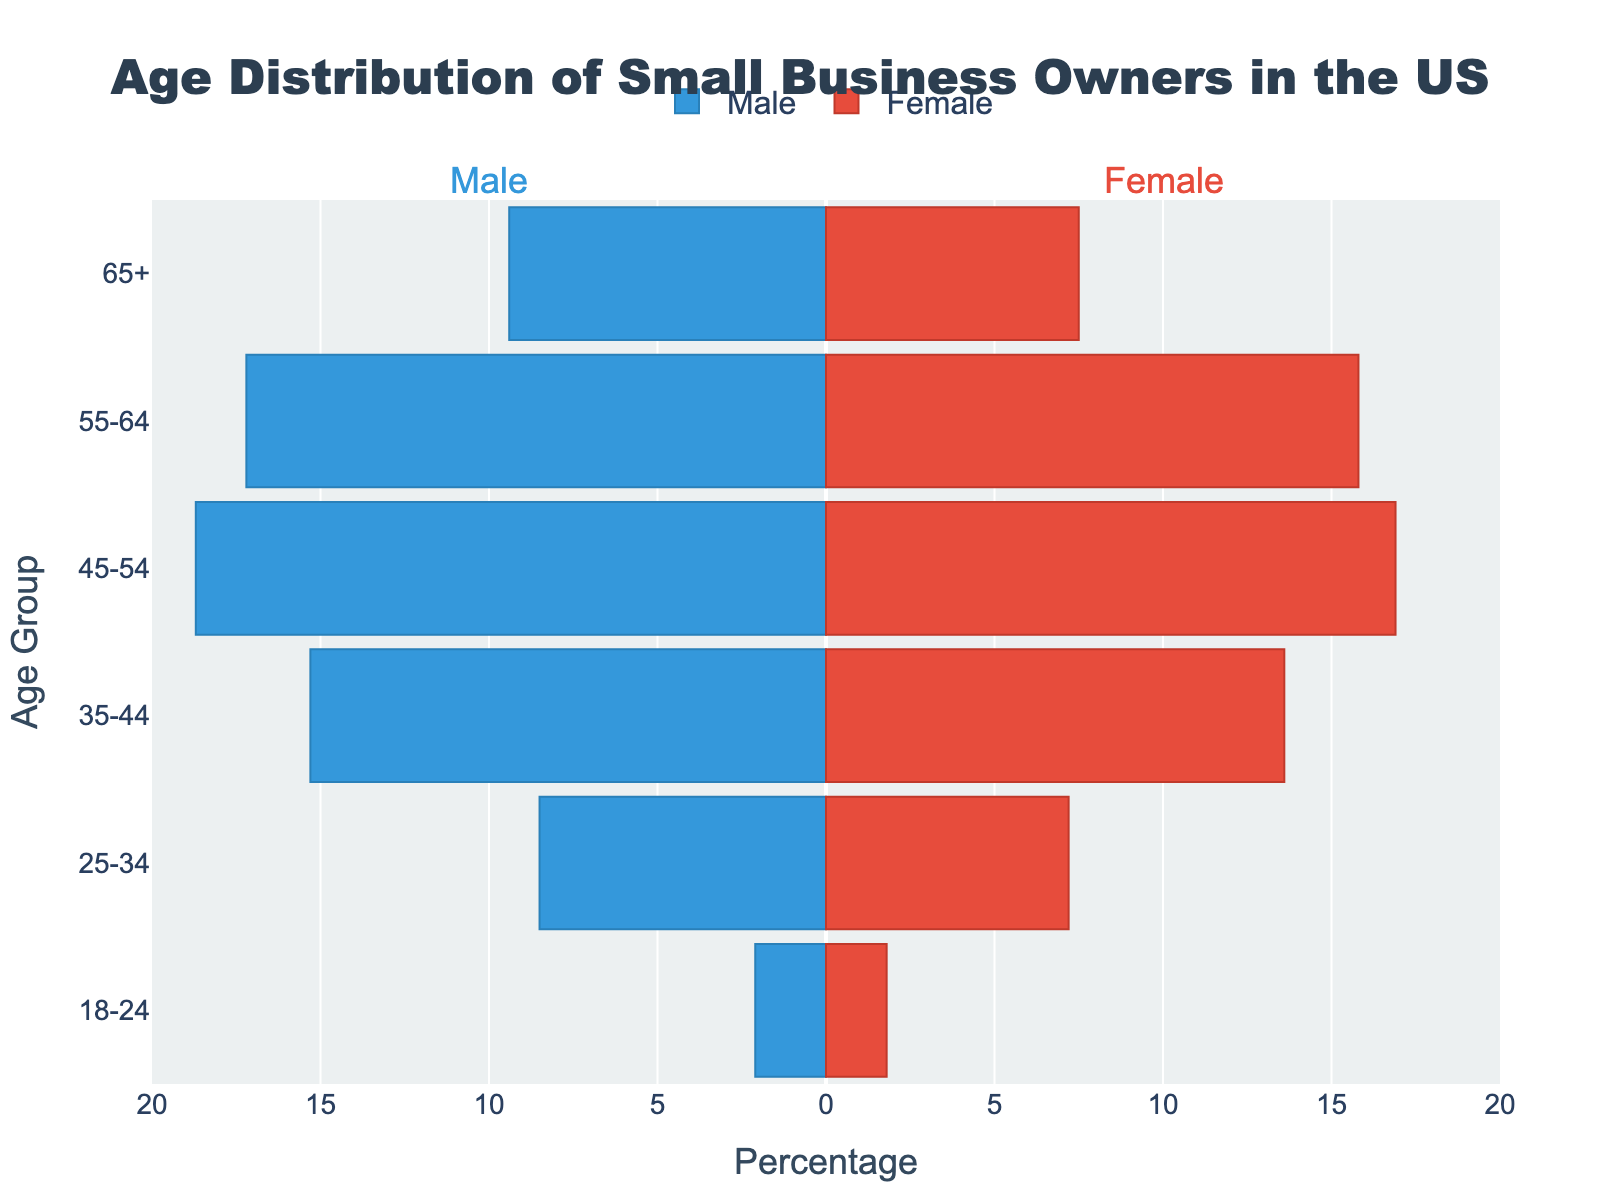What is the title of the figure? The title of the figure is displayed at the top center and reads "Age Distribution of Small Business Owners in the US".
Answer: Age Distribution of Small Business Owners in the US Which age group has the highest percentage of male small business owners? By observing the male bars on the left side of the figure, the 45-54 age group has the longest bar extending to approximately -18.7%, indicating the highest percentage.
Answer: 45-54 How does the percentage of female small business owners in the 35-44 age group compare to that of males in the same group? For the 35-44 age group, the female bar extends to 13.6% and the male bar extends to -15.3%. Comparing the lengths, the percentage of female small business owners is 13.6%, which is less than the male percentage of 15.3%.
Answer: Less What is the approximate total percentage of small business owners in the 55-64 age group? Adding the percentages of both males and females in the 55-64 age group (males: 17.2% and females: 15.8%), the total is approximately 33.0%.
Answer: 33.0% For which age group is the gap between male and female small business owners the smallest? By examining the lengths of the bars for each age group and comparing the differences, the gap between males (2.1%) and females (1.8%) is smallest in the 18-24 age group (difference of 0.3%).
Answer: 18-24 In the 65+ age group, which gender has a higher percentage of small business owners and by how much? The 65+ age group has female small business owners at 7.5% and male small business owners at 9.4%. Males have a higher percentage than females by 9.4% - 7.5% = 1.9%.
Answer: Males by 1.9% What is the combined percentage of male and female small business owners in the 25-34 age group? Adding the percentages of males (8.5%) and females (7.2%) in the 25-34 age group gives a combined percentage of 15.7%.
Answer: 15.7% Which age group has the lowest percentage of female small business owners? By looking at the female bars across all age groups, the 18-24 age group has the shortest bar at 1.8%, indicating the lowest percentage of female small business owners.
Answer: 18-24 